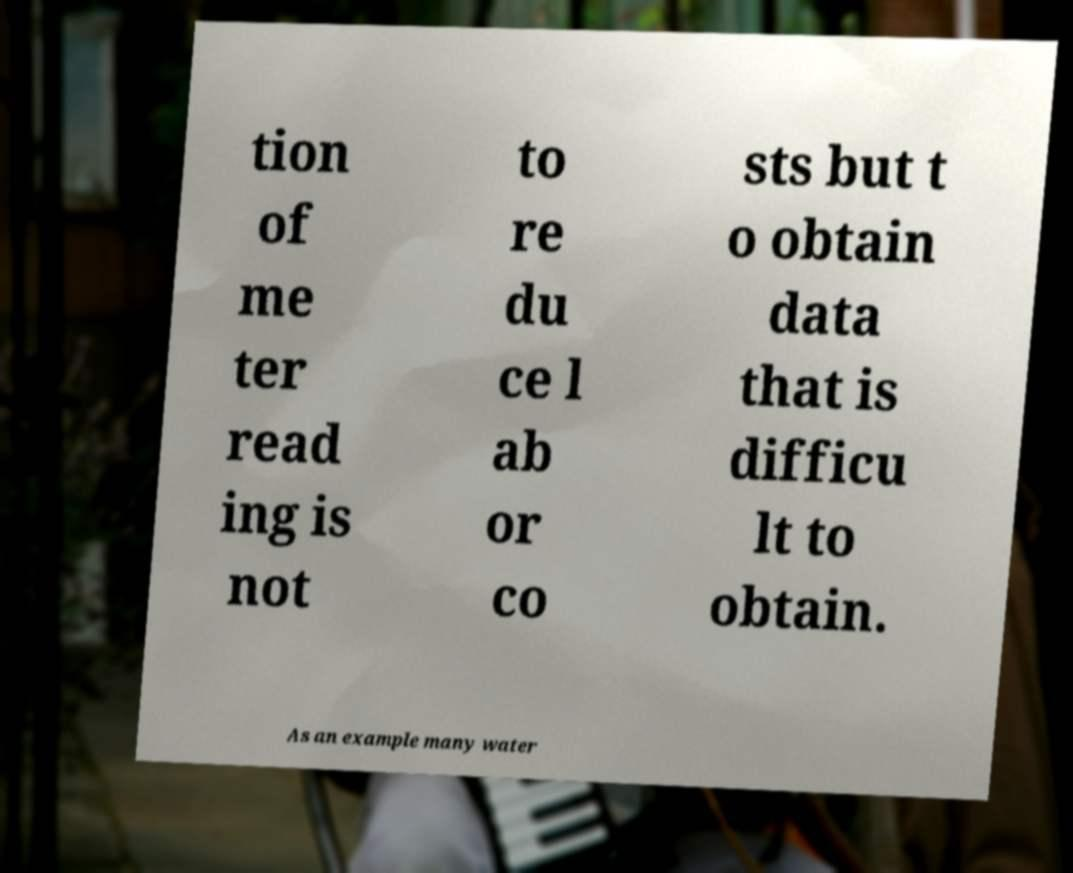Could you extract and type out the text from this image? tion of me ter read ing is not to re du ce l ab or co sts but t o obtain data that is difficu lt to obtain. As an example many water 